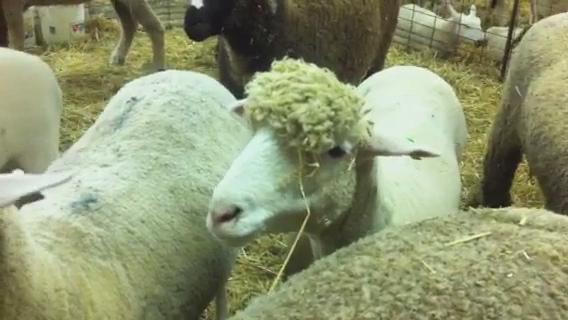What does the fur resemble?
Indicate the correct response and explain using: 'Answer: answer
Rationale: rationale.'
Options: Glasses, toque, hat, mug. Answer: hat.
Rationale: It appears that whoever sheared this sheep has a fine sense of humor, and the remaining fuzzy cap on this sheep's head is adorable. 